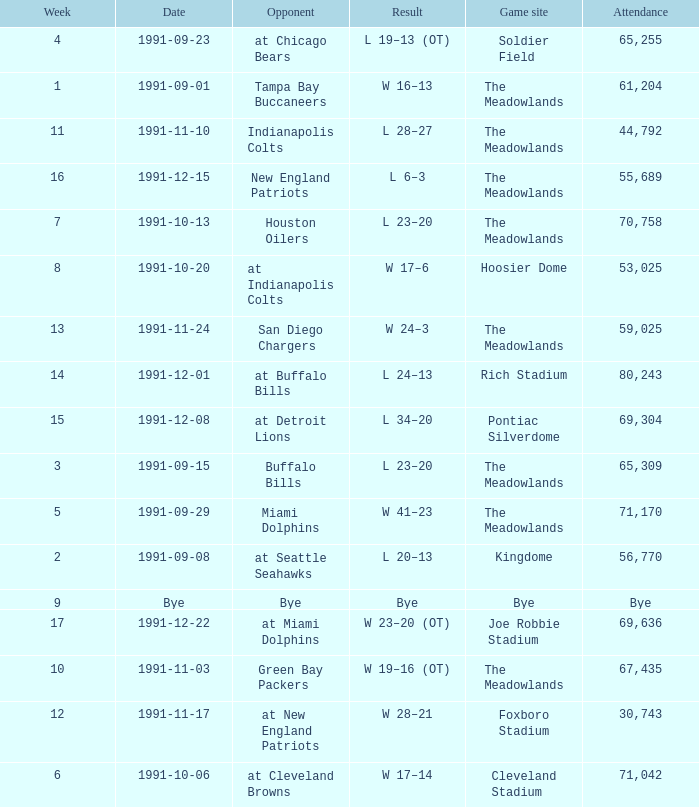Which Opponent was played on 1991-10-13? Houston Oilers. 